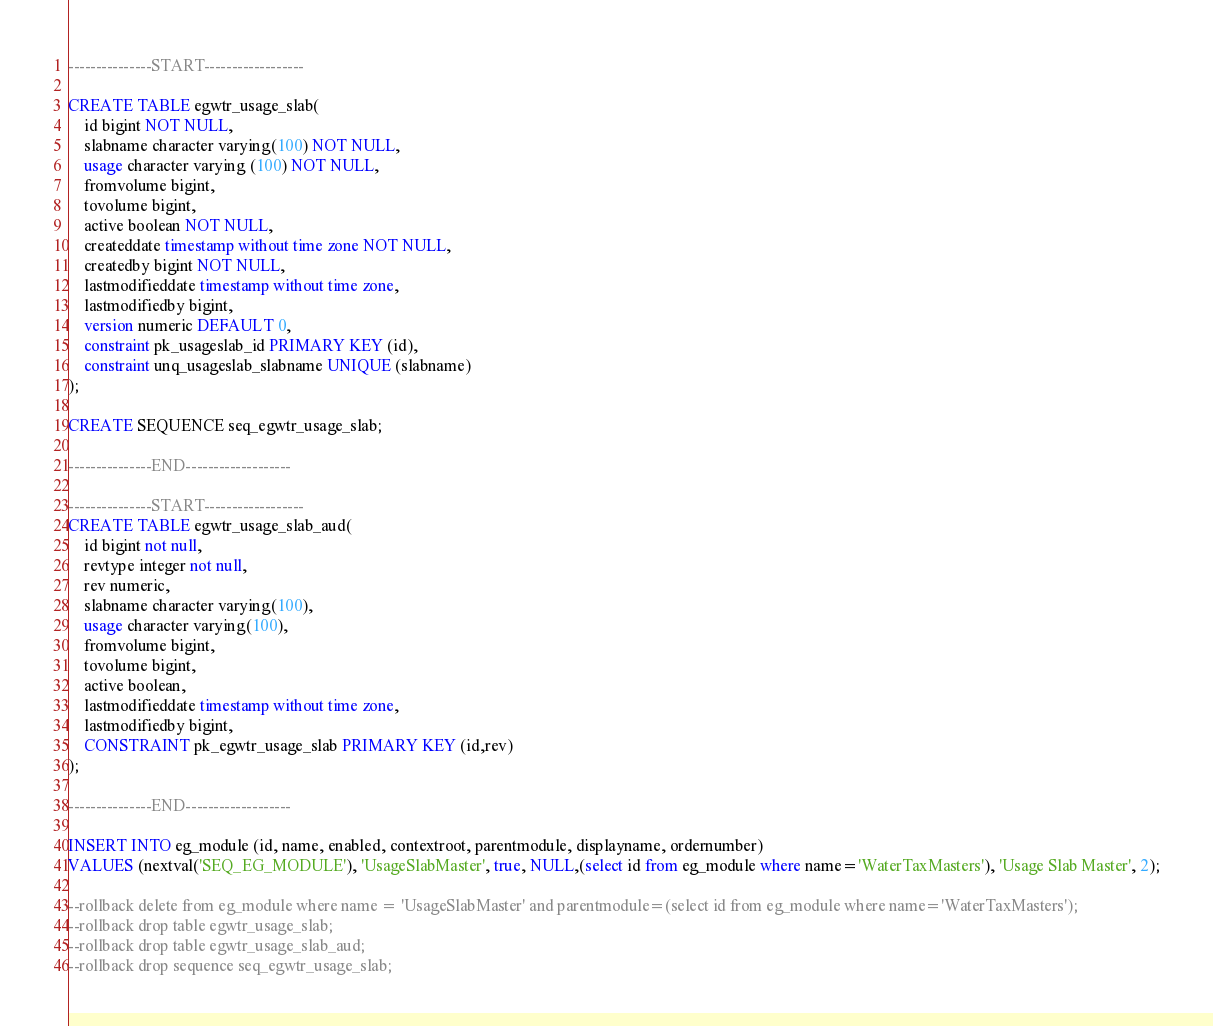<code> <loc_0><loc_0><loc_500><loc_500><_SQL_>
---------------START------------------

CREATE TABLE egwtr_usage_slab(
	id bigint NOT NULL,
	slabname character varying(100) NOT NULL,
	usage character varying (100) NOT NULL,
	fromvolume bigint,
	tovolume bigint,
	active boolean NOT NULL,
	createddate timestamp without time zone NOT NULL,
	createdby bigint NOT NULL,
	lastmodifieddate timestamp without time zone,
	lastmodifiedby bigint,
	version numeric DEFAULT 0,
	constraint pk_usageslab_id PRIMARY KEY (id),
	constraint unq_usageslab_slabname UNIQUE (slabname)
);

CREATE SEQUENCE seq_egwtr_usage_slab;

---------------END-------------------

---------------START------------------
CREATE TABLE egwtr_usage_slab_aud(
	id bigint not null,
	revtype integer not null,
	rev numeric,
	slabname character varying(100),
	usage character varying(100),
	fromvolume bigint,
	tovolume bigint,
	active boolean,
	lastmodifieddate timestamp without time zone,
	lastmodifiedby bigint,
	CONSTRAINT pk_egwtr_usage_slab PRIMARY KEY (id,rev)
);

---------------END-------------------

INSERT INTO eg_module (id, name, enabled, contextroot, parentmodule, displayname, ordernumber) 
VALUES (nextval('SEQ_EG_MODULE'), 'UsageSlabMaster', true, NULL,(select id from eg_module where name='WaterTaxMasters'), 'Usage Slab Master', 2);

--rollback delete from eg_module where name = 'UsageSlabMaster' and parentmodule=(select id from eg_module where name='WaterTaxMasters');
--rollback drop table egwtr_usage_slab;
--rollback drop table egwtr_usage_slab_aud;
--rollback drop sequence seq_egwtr_usage_slab;








</code> 